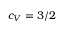<formula> <loc_0><loc_0><loc_500><loc_500>c _ { V } = 3 / 2</formula> 